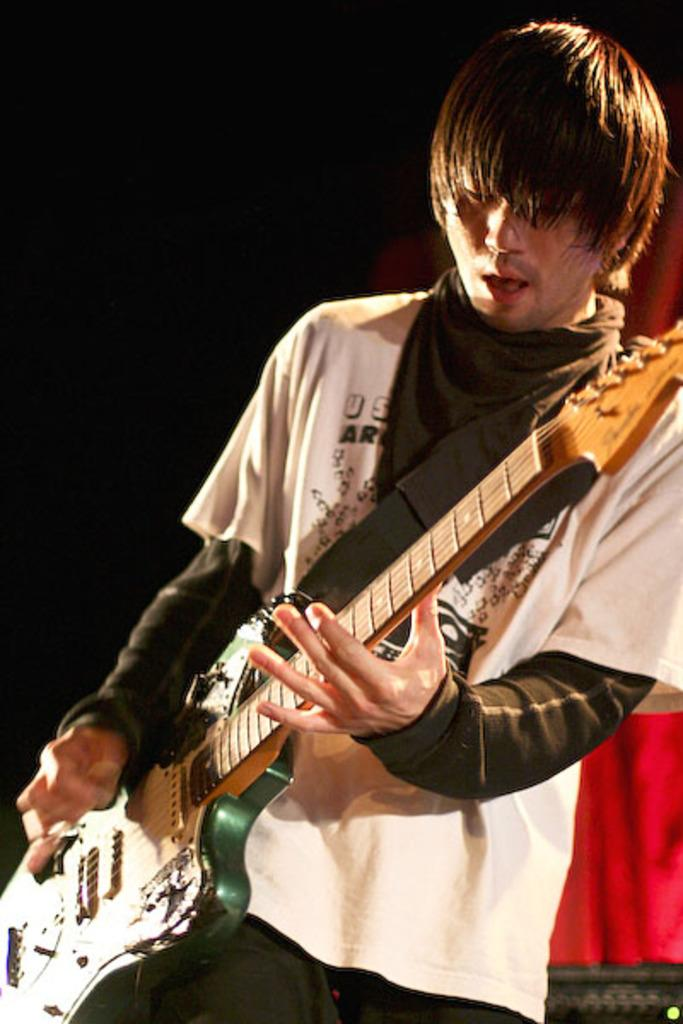What is the main subject of the image? There is a person in the image. What is the person wearing? The person is wearing a white and black t-shirt. What object is the person holding? The person is holding a guitar. What is the person doing with the guitar? The person is playing the guitar. What type of gold jewelry is the person wearing in the image? There is no mention of any gold jewelry being worn by the person in the image. What committee is the person a part of in the image? There is no mention of any committee in the image. 